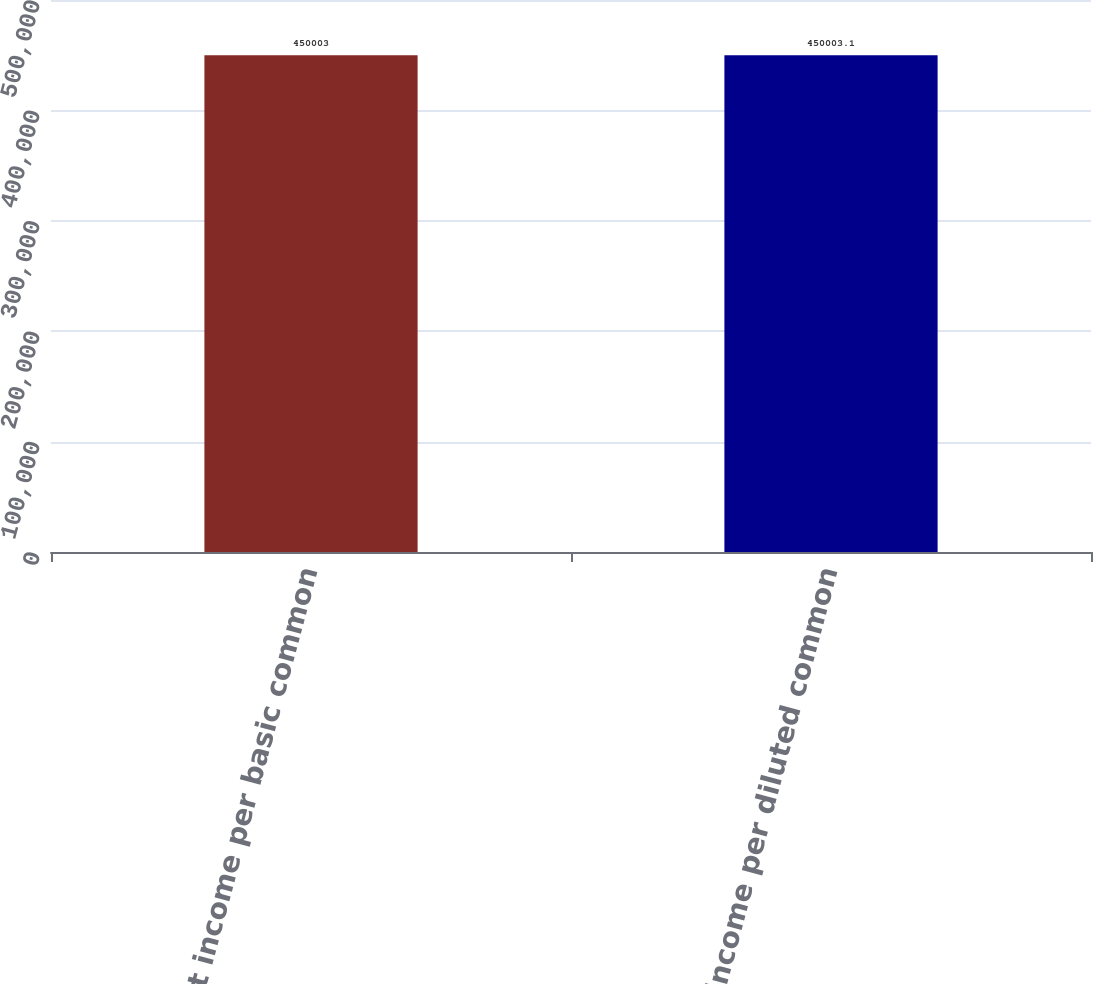Convert chart. <chart><loc_0><loc_0><loc_500><loc_500><bar_chart><fcel>Net income per basic common<fcel>Net income per diluted common<nl><fcel>450003<fcel>450003<nl></chart> 